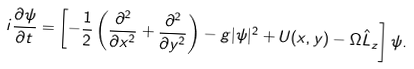<formula> <loc_0><loc_0><loc_500><loc_500>i \frac { \partial \psi } { \partial t } = \left [ - \frac { 1 } { 2 } \left ( \frac { \partial ^ { 2 } } { \partial x ^ { 2 } } + \frac { \partial ^ { 2 } } { \partial y ^ { 2 } } \right ) - g | \psi | ^ { 2 } + U ( x , y ) - \Omega \hat { L } _ { z } \right ] \psi .</formula> 